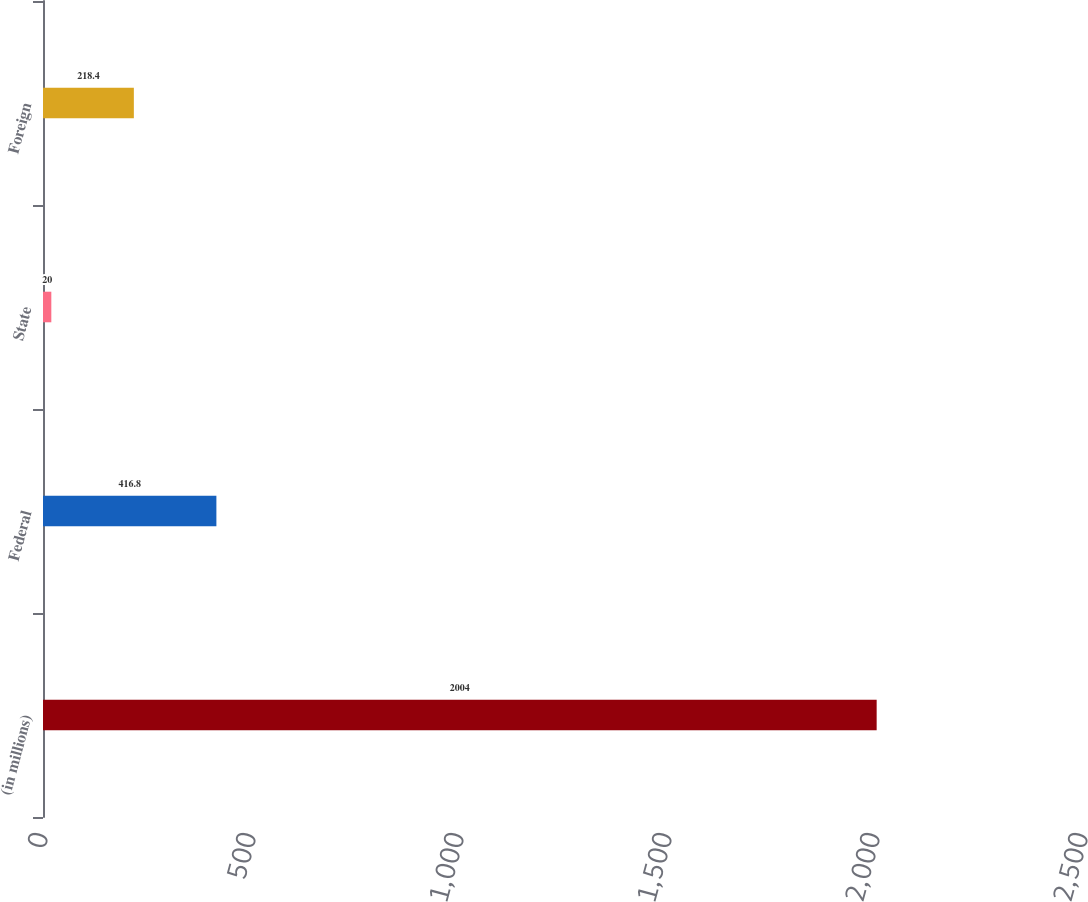Convert chart. <chart><loc_0><loc_0><loc_500><loc_500><bar_chart><fcel>(in millions)<fcel>Federal<fcel>State<fcel>Foreign<nl><fcel>2004<fcel>416.8<fcel>20<fcel>218.4<nl></chart> 